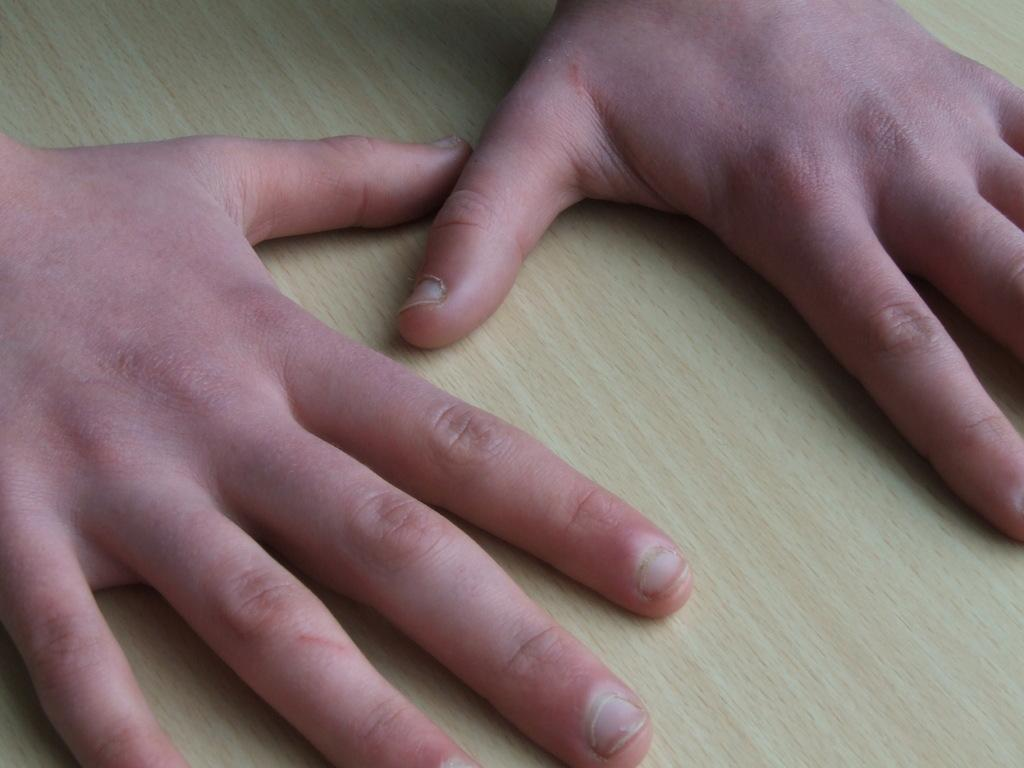What is the main focus of the image? The image shows a close view of hands. Whose hands are visible in the image? The hands belong to boys. What is the surface beneath the hands in the image? The hands are on a wooden table top. What hobbies do the boys have, as indicated by the image? The image does not provide any information about the boys' hobbies; it only shows their hands on a wooden table top. 